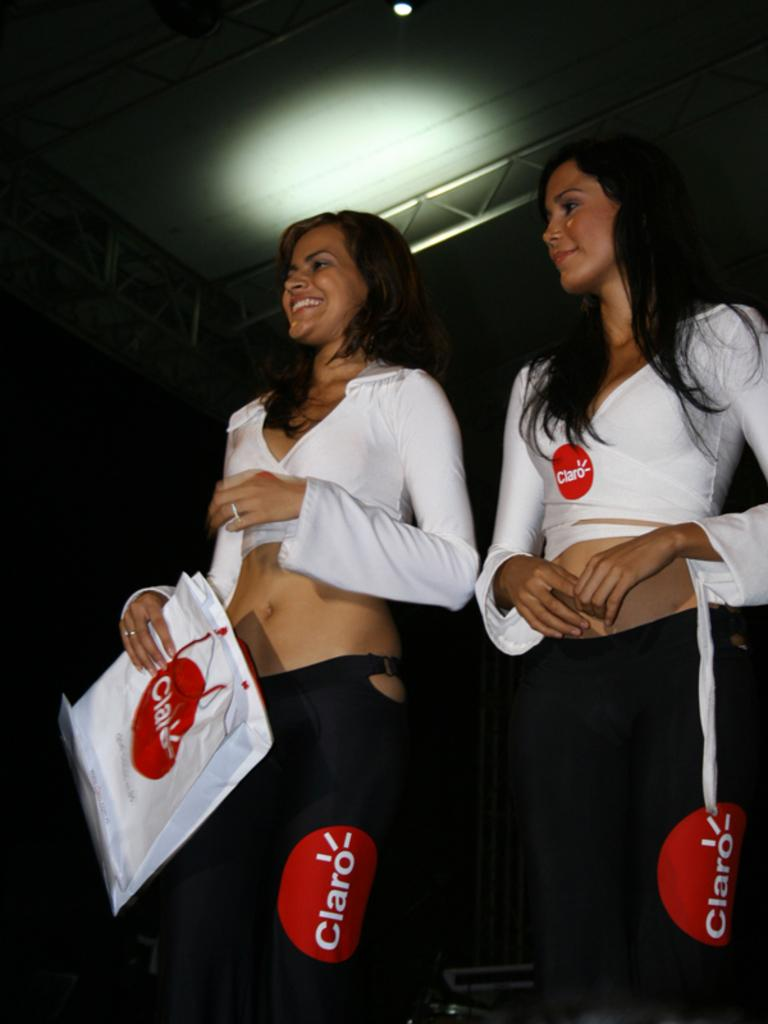Provide a one-sentence caption for the provided image. 2 women wearing black pants with a red circle with Claro written in white. 